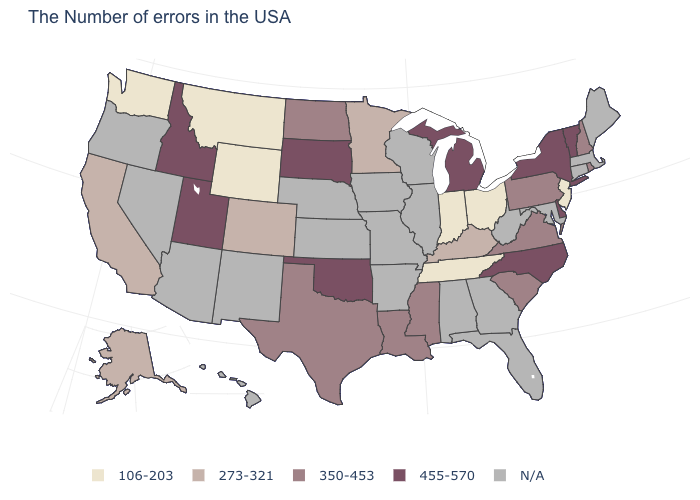Name the states that have a value in the range 273-321?
Keep it brief. Kentucky, Minnesota, Colorado, California, Alaska. What is the value of Massachusetts?
Give a very brief answer. N/A. Among the states that border Vermont , which have the lowest value?
Quick response, please. New Hampshire. What is the value of Arizona?
Concise answer only. N/A. What is the lowest value in the South?
Give a very brief answer. 106-203. Name the states that have a value in the range N/A?
Short answer required. Maine, Massachusetts, Connecticut, Maryland, West Virginia, Florida, Georgia, Alabama, Wisconsin, Illinois, Missouri, Arkansas, Iowa, Kansas, Nebraska, New Mexico, Arizona, Nevada, Oregon, Hawaii. Does Delaware have the lowest value in the South?
Short answer required. No. Name the states that have a value in the range 350-453?
Write a very short answer. Rhode Island, New Hampshire, Pennsylvania, Virginia, South Carolina, Mississippi, Louisiana, Texas, North Dakota. What is the value of Mississippi?
Write a very short answer. 350-453. What is the lowest value in states that border Arkansas?
Be succinct. 106-203. Name the states that have a value in the range N/A?
Write a very short answer. Maine, Massachusetts, Connecticut, Maryland, West Virginia, Florida, Georgia, Alabama, Wisconsin, Illinois, Missouri, Arkansas, Iowa, Kansas, Nebraska, New Mexico, Arizona, Nevada, Oregon, Hawaii. Which states hav the highest value in the MidWest?
Quick response, please. Michigan, South Dakota. Among the states that border Mississippi , which have the highest value?
Give a very brief answer. Louisiana. Does the first symbol in the legend represent the smallest category?
Keep it brief. Yes. 